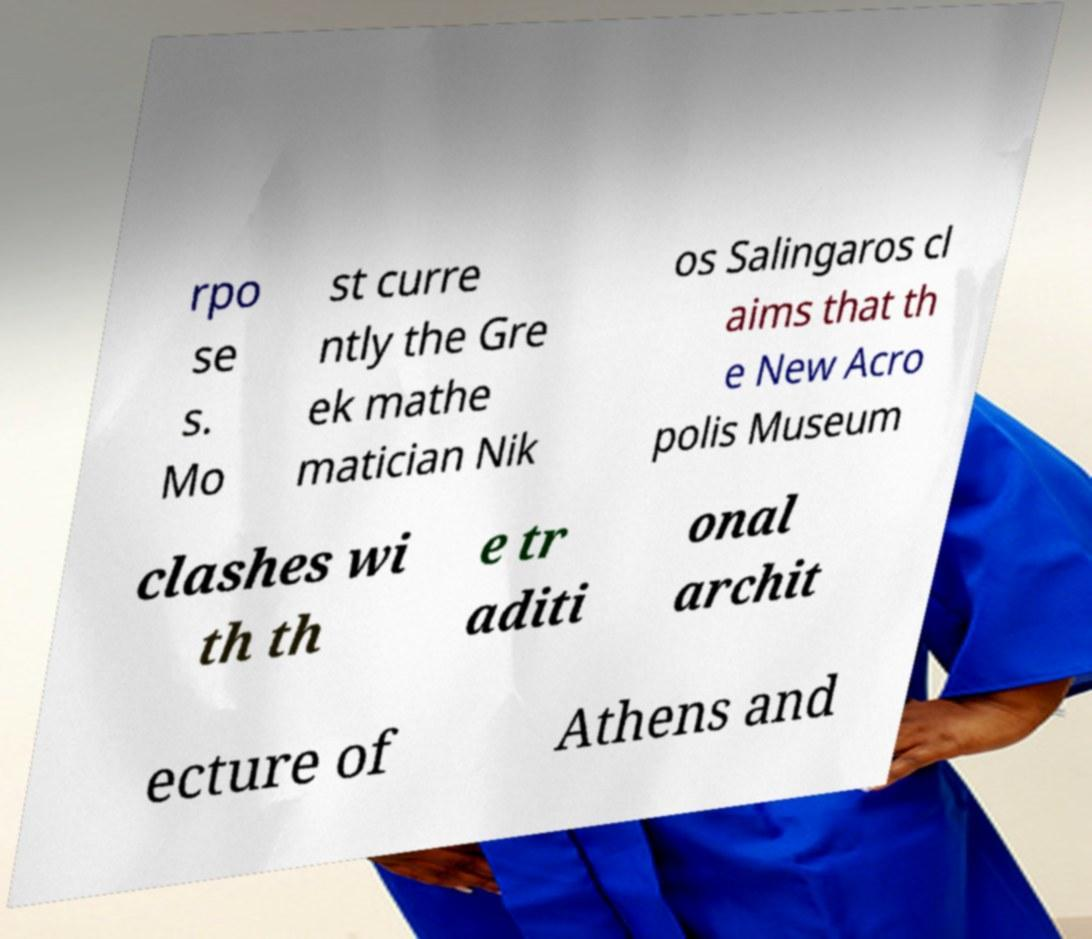I need the written content from this picture converted into text. Can you do that? rpo se s. Mo st curre ntly the Gre ek mathe matician Nik os Salingaros cl aims that th e New Acro polis Museum clashes wi th th e tr aditi onal archit ecture of Athens and 